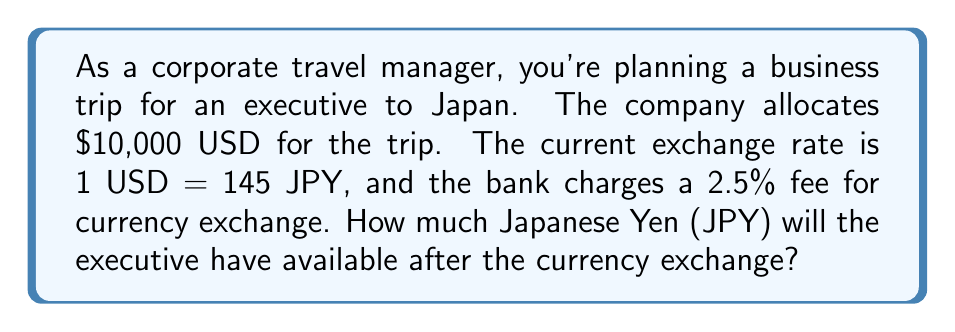Teach me how to tackle this problem. Let's approach this problem step-by-step:

1. First, we need to calculate the amount of USD available after the bank's fee:
   * Fee percentage = 2.5% = 0.025
   * Fee amount = $10,000 * 0.025 = $250
   * USD available after fee = $10,000 - $250 = $9,750

2. Now, we can calculate the exchange from USD to JPY:
   * Exchange rate: 1 USD = 145 JPY
   * Amount in JPY = $9,750 * 145

3. Let's perform the calculation:
   $$9,750 * 145 = 1,413,750 \text{ JPY}$$

Therefore, the mathematical representation of this problem can be expressed as:

$$\text{JPY} = (10,000 * (1 - 0.025)) * 145 = 1,413,750$$
Answer: 1,413,750 JPY 